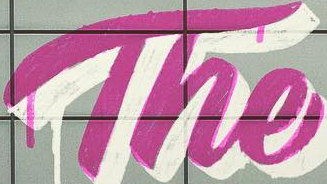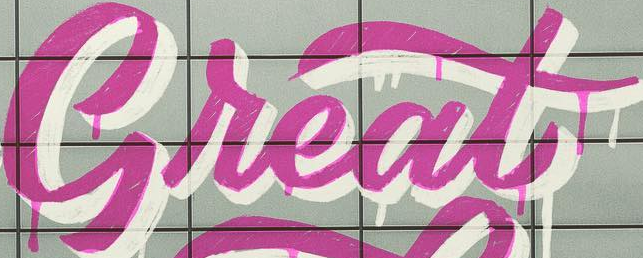Transcribe the words shown in these images in order, separated by a semicolon. The; Great 